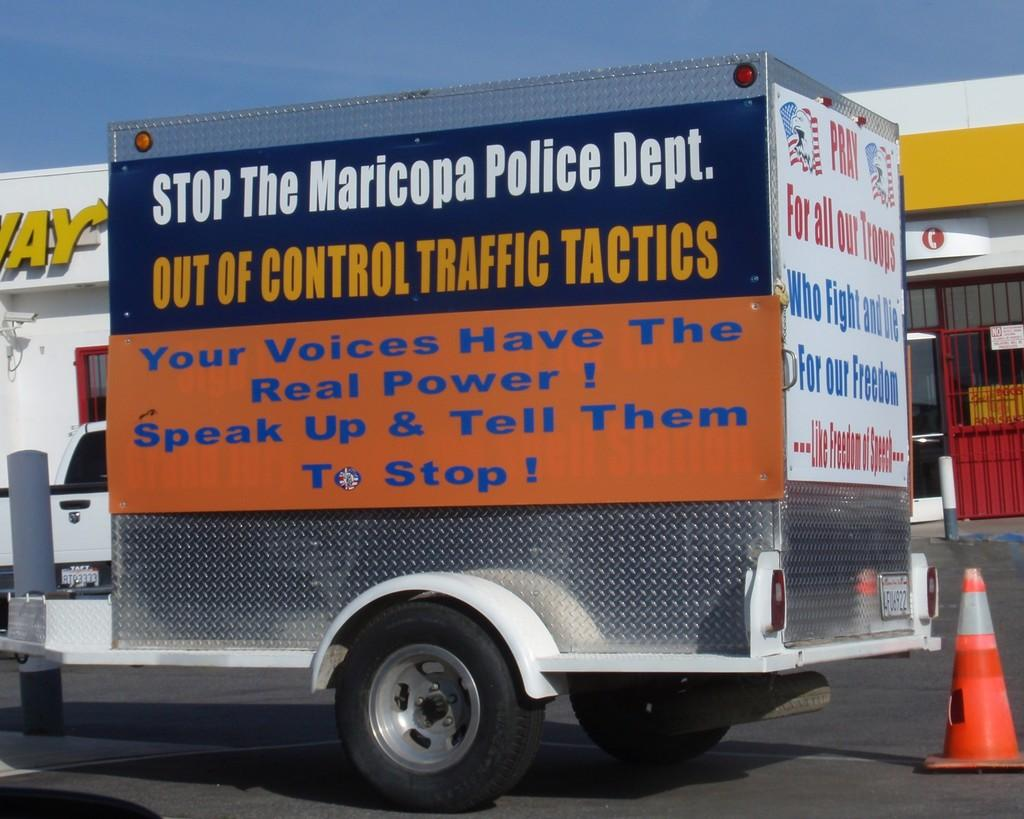What is the main subject in the image? There is a vehicle in the image. What can be seen on the road in the image? There is a traffic cone on the road in the image. What type of signage is present in the image? There are posters and name boards in the image. What are the rods used for in the image? The purpose of the rods is not specified in the image, but they are visible. What else can be seen in the image besides the mentioned objects? There are other objects in the image, but their specific details are not provided. What is visible in the background of the image? The sky is visible in the background of the image. Can you see any children playing on the playground in the image? There is no playground present in the image. What type of powder is being used to clean the vehicle in the image? There is no powder or cleaning activity visible in the image. 